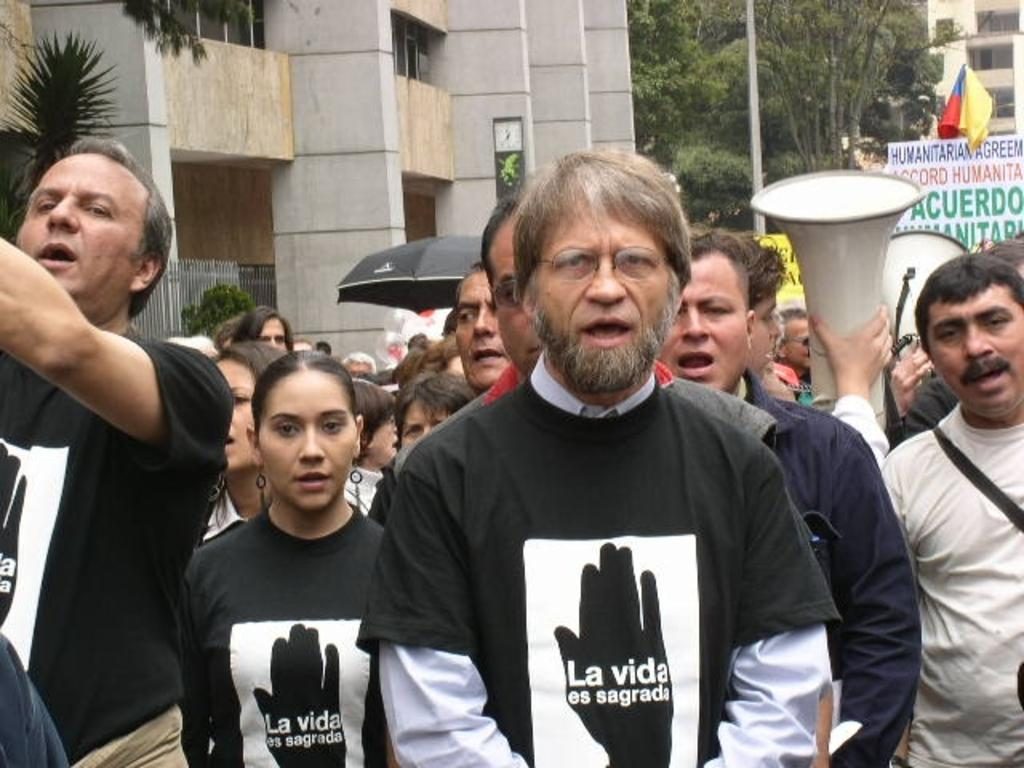What is happening in the image? There are people standing in the image. What can be seen in the background of the image? There is a building, a flag, an umbrella, speakers, and a board with text in the background of the image. Are there any natural elements present in the image? Yes, trees are present in the image. What type of impulse can be seen traveling through the cable in the image? There is no cable present in the image, so it is not possible to determine if any impulse is traveling through it. 